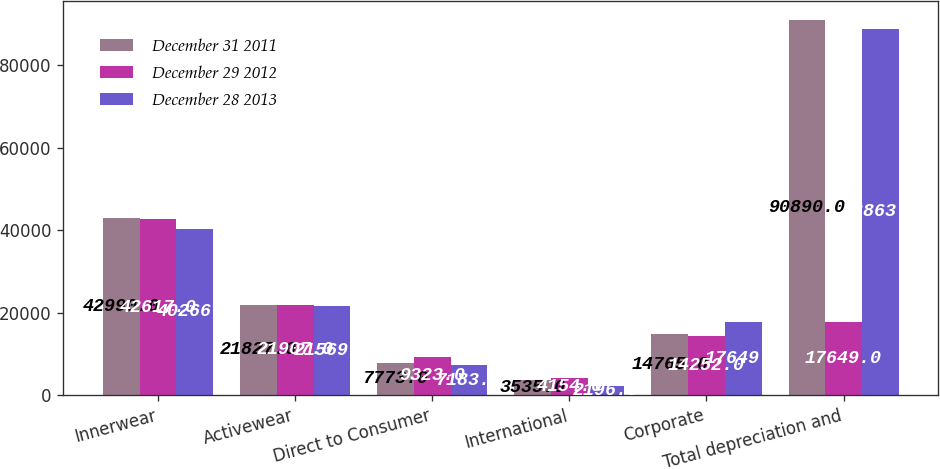<chart> <loc_0><loc_0><loc_500><loc_500><stacked_bar_chart><ecel><fcel>Innerwear<fcel>Activewear<fcel>Direct to Consumer<fcel>International<fcel>Corporate<fcel>Total depreciation and<nl><fcel>December 31 2011<fcel>42990<fcel>21827<fcel>7773<fcel>3535<fcel>14765<fcel>90890<nl><fcel>December 29 2012<fcel>42617<fcel>21907<fcel>9323<fcel>4154<fcel>14252<fcel>17649<nl><fcel>December 28 2013<fcel>40266<fcel>21569<fcel>7183<fcel>2196<fcel>17649<fcel>88863<nl></chart> 